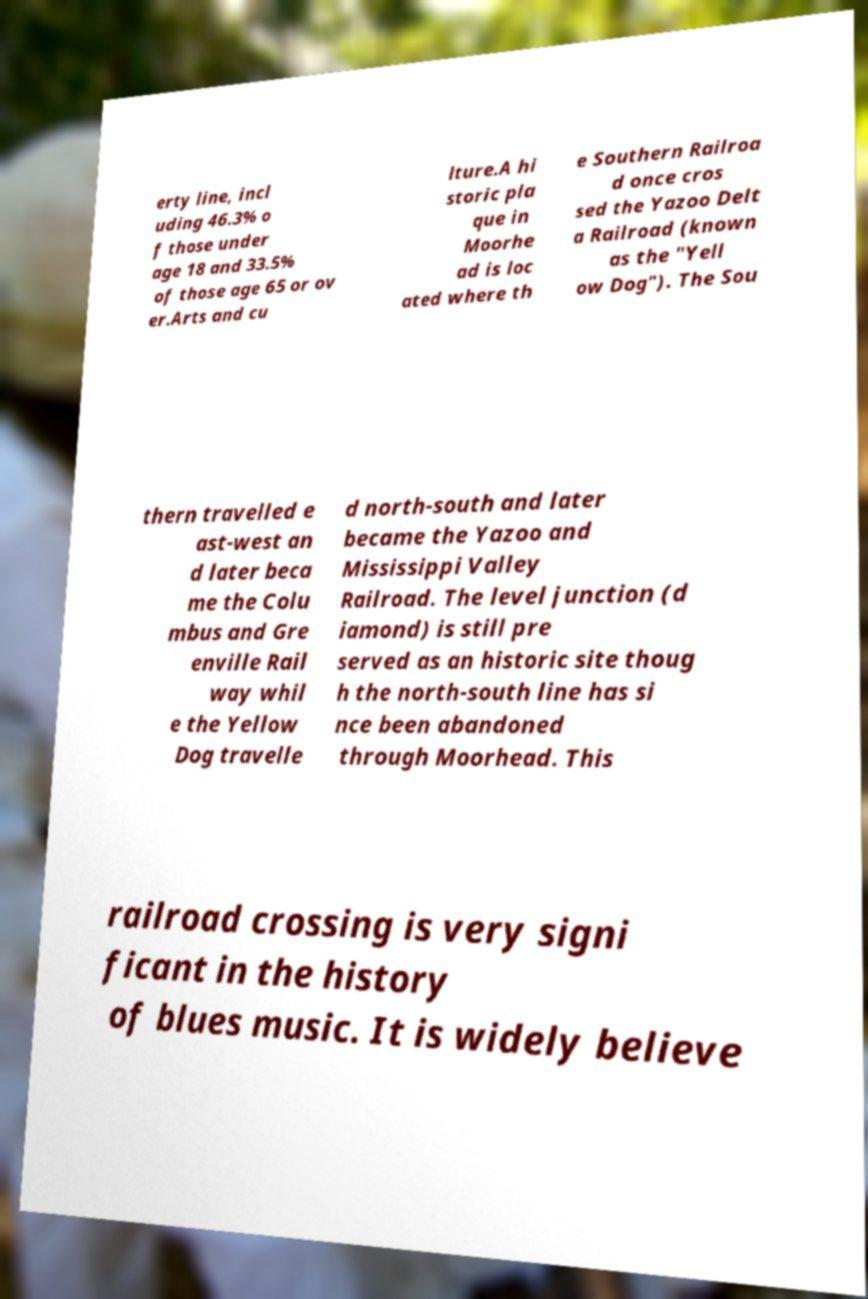Could you assist in decoding the text presented in this image and type it out clearly? erty line, incl uding 46.3% o f those under age 18 and 33.5% of those age 65 or ov er.Arts and cu lture.A hi storic pla que in Moorhe ad is loc ated where th e Southern Railroa d once cros sed the Yazoo Delt a Railroad (known as the "Yell ow Dog"). The Sou thern travelled e ast-west an d later beca me the Colu mbus and Gre enville Rail way whil e the Yellow Dog travelle d north-south and later became the Yazoo and Mississippi Valley Railroad. The level junction (d iamond) is still pre served as an historic site thoug h the north-south line has si nce been abandoned through Moorhead. This railroad crossing is very signi ficant in the history of blues music. It is widely believe 